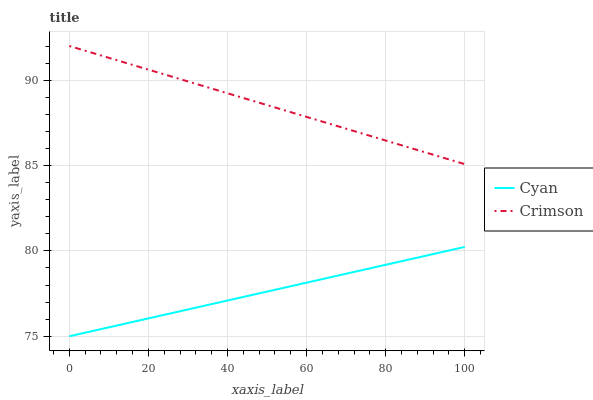Does Cyan have the minimum area under the curve?
Answer yes or no. Yes. Does Crimson have the maximum area under the curve?
Answer yes or no. Yes. Does Cyan have the maximum area under the curve?
Answer yes or no. No. Is Crimson the smoothest?
Answer yes or no. Yes. Is Cyan the roughest?
Answer yes or no. Yes. Is Cyan the smoothest?
Answer yes or no. No. Does Cyan have the lowest value?
Answer yes or no. Yes. Does Crimson have the highest value?
Answer yes or no. Yes. Does Cyan have the highest value?
Answer yes or no. No. Is Cyan less than Crimson?
Answer yes or no. Yes. Is Crimson greater than Cyan?
Answer yes or no. Yes. Does Cyan intersect Crimson?
Answer yes or no. No. 